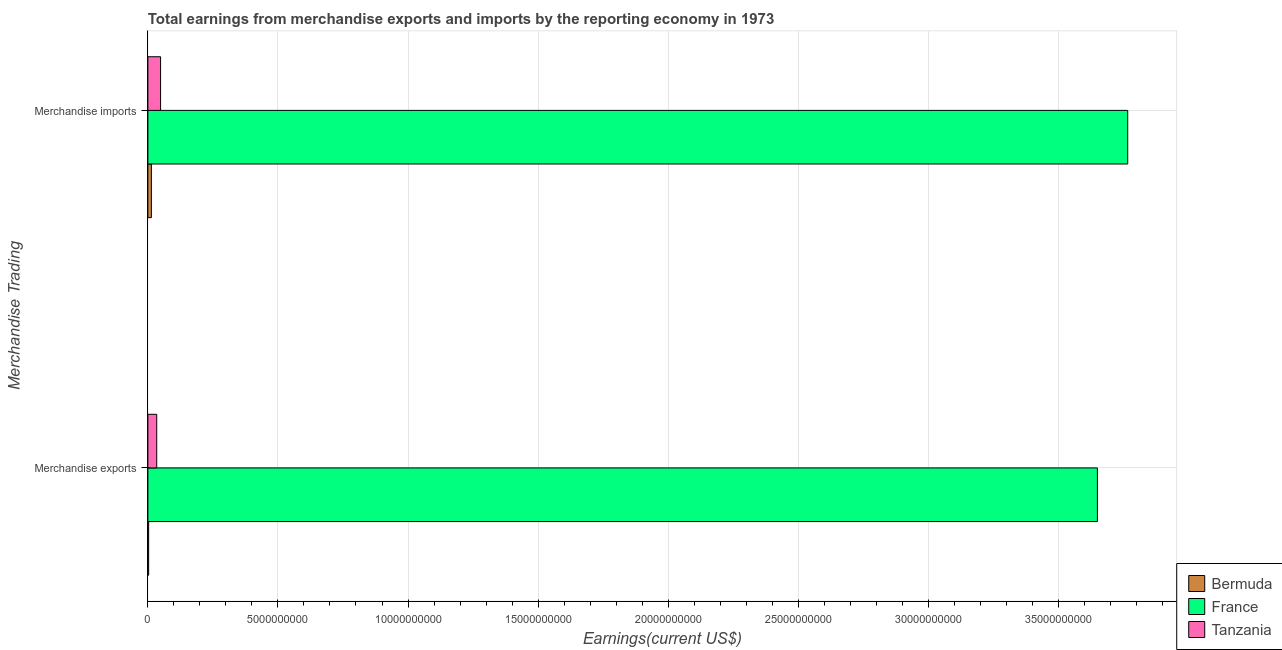How many different coloured bars are there?
Give a very brief answer. 3. Are the number of bars on each tick of the Y-axis equal?
Keep it short and to the point. Yes. How many bars are there on the 1st tick from the top?
Give a very brief answer. 3. How many bars are there on the 2nd tick from the bottom?
Your answer should be very brief. 3. What is the label of the 2nd group of bars from the top?
Your answer should be very brief. Merchandise exports. What is the earnings from merchandise exports in France?
Keep it short and to the point. 3.65e+1. Across all countries, what is the maximum earnings from merchandise exports?
Your answer should be compact. 3.65e+1. Across all countries, what is the minimum earnings from merchandise exports?
Offer a terse response. 2.98e+07. In which country was the earnings from merchandise exports minimum?
Provide a short and direct response. Bermuda. What is the total earnings from merchandise exports in the graph?
Give a very brief answer. 3.69e+1. What is the difference between the earnings from merchandise exports in Tanzania and that in France?
Offer a terse response. -3.62e+1. What is the difference between the earnings from merchandise imports in France and the earnings from merchandise exports in Bermuda?
Offer a terse response. 3.76e+1. What is the average earnings from merchandise exports per country?
Provide a short and direct response. 1.23e+1. What is the difference between the earnings from merchandise exports and earnings from merchandise imports in Bermuda?
Ensure brevity in your answer.  -1.05e+08. What is the ratio of the earnings from merchandise exports in Bermuda to that in France?
Offer a very short reply. 0. In how many countries, is the earnings from merchandise imports greater than the average earnings from merchandise imports taken over all countries?
Ensure brevity in your answer.  1. What does the 3rd bar from the top in Merchandise imports represents?
Your answer should be very brief. Bermuda. How many bars are there?
Ensure brevity in your answer.  6. What is the difference between two consecutive major ticks on the X-axis?
Keep it short and to the point. 5.00e+09. Are the values on the major ticks of X-axis written in scientific E-notation?
Offer a very short reply. No. Does the graph contain any zero values?
Offer a very short reply. No. Where does the legend appear in the graph?
Offer a very short reply. Bottom right. What is the title of the graph?
Keep it short and to the point. Total earnings from merchandise exports and imports by the reporting economy in 1973. Does "High income" appear as one of the legend labels in the graph?
Offer a very short reply. No. What is the label or title of the X-axis?
Your response must be concise. Earnings(current US$). What is the label or title of the Y-axis?
Ensure brevity in your answer.  Merchandise Trading. What is the Earnings(current US$) of Bermuda in Merchandise exports?
Provide a succinct answer. 2.98e+07. What is the Earnings(current US$) in France in Merchandise exports?
Keep it short and to the point. 3.65e+1. What is the Earnings(current US$) of Tanzania in Merchandise exports?
Give a very brief answer. 3.41e+08. What is the Earnings(current US$) of Bermuda in Merchandise imports?
Give a very brief answer. 1.35e+08. What is the Earnings(current US$) in France in Merchandise imports?
Give a very brief answer. 3.77e+1. What is the Earnings(current US$) of Tanzania in Merchandise imports?
Offer a terse response. 4.88e+08. Across all Merchandise Trading, what is the maximum Earnings(current US$) in Bermuda?
Your response must be concise. 1.35e+08. Across all Merchandise Trading, what is the maximum Earnings(current US$) in France?
Ensure brevity in your answer.  3.77e+1. Across all Merchandise Trading, what is the maximum Earnings(current US$) of Tanzania?
Offer a very short reply. 4.88e+08. Across all Merchandise Trading, what is the minimum Earnings(current US$) of Bermuda?
Your answer should be very brief. 2.98e+07. Across all Merchandise Trading, what is the minimum Earnings(current US$) of France?
Offer a very short reply. 3.65e+1. Across all Merchandise Trading, what is the minimum Earnings(current US$) of Tanzania?
Offer a very short reply. 3.41e+08. What is the total Earnings(current US$) in Bermuda in the graph?
Offer a terse response. 1.65e+08. What is the total Earnings(current US$) of France in the graph?
Offer a terse response. 7.42e+1. What is the total Earnings(current US$) in Tanzania in the graph?
Provide a short and direct response. 8.29e+08. What is the difference between the Earnings(current US$) of Bermuda in Merchandise exports and that in Merchandise imports?
Ensure brevity in your answer.  -1.05e+08. What is the difference between the Earnings(current US$) in France in Merchandise exports and that in Merchandise imports?
Provide a short and direct response. -1.16e+09. What is the difference between the Earnings(current US$) in Tanzania in Merchandise exports and that in Merchandise imports?
Provide a succinct answer. -1.48e+08. What is the difference between the Earnings(current US$) of Bermuda in Merchandise exports and the Earnings(current US$) of France in Merchandise imports?
Offer a terse response. -3.76e+1. What is the difference between the Earnings(current US$) in Bermuda in Merchandise exports and the Earnings(current US$) in Tanzania in Merchandise imports?
Offer a very short reply. -4.59e+08. What is the difference between the Earnings(current US$) of France in Merchandise exports and the Earnings(current US$) of Tanzania in Merchandise imports?
Provide a short and direct response. 3.60e+1. What is the average Earnings(current US$) of Bermuda per Merchandise Trading?
Offer a very short reply. 8.25e+07. What is the average Earnings(current US$) of France per Merchandise Trading?
Ensure brevity in your answer.  3.71e+1. What is the average Earnings(current US$) of Tanzania per Merchandise Trading?
Your answer should be very brief. 4.15e+08. What is the difference between the Earnings(current US$) of Bermuda and Earnings(current US$) of France in Merchandise exports?
Offer a terse response. -3.65e+1. What is the difference between the Earnings(current US$) of Bermuda and Earnings(current US$) of Tanzania in Merchandise exports?
Your response must be concise. -3.11e+08. What is the difference between the Earnings(current US$) of France and Earnings(current US$) of Tanzania in Merchandise exports?
Keep it short and to the point. 3.62e+1. What is the difference between the Earnings(current US$) in Bermuda and Earnings(current US$) in France in Merchandise imports?
Provide a succinct answer. -3.75e+1. What is the difference between the Earnings(current US$) in Bermuda and Earnings(current US$) in Tanzania in Merchandise imports?
Your answer should be compact. -3.53e+08. What is the difference between the Earnings(current US$) in France and Earnings(current US$) in Tanzania in Merchandise imports?
Ensure brevity in your answer.  3.72e+1. What is the ratio of the Earnings(current US$) of Bermuda in Merchandise exports to that in Merchandise imports?
Provide a short and direct response. 0.22. What is the ratio of the Earnings(current US$) of France in Merchandise exports to that in Merchandise imports?
Make the answer very short. 0.97. What is the ratio of the Earnings(current US$) in Tanzania in Merchandise exports to that in Merchandise imports?
Ensure brevity in your answer.  0.7. What is the difference between the highest and the second highest Earnings(current US$) of Bermuda?
Offer a very short reply. 1.05e+08. What is the difference between the highest and the second highest Earnings(current US$) of France?
Keep it short and to the point. 1.16e+09. What is the difference between the highest and the second highest Earnings(current US$) in Tanzania?
Your answer should be very brief. 1.48e+08. What is the difference between the highest and the lowest Earnings(current US$) of Bermuda?
Provide a succinct answer. 1.05e+08. What is the difference between the highest and the lowest Earnings(current US$) of France?
Your answer should be very brief. 1.16e+09. What is the difference between the highest and the lowest Earnings(current US$) in Tanzania?
Provide a short and direct response. 1.48e+08. 